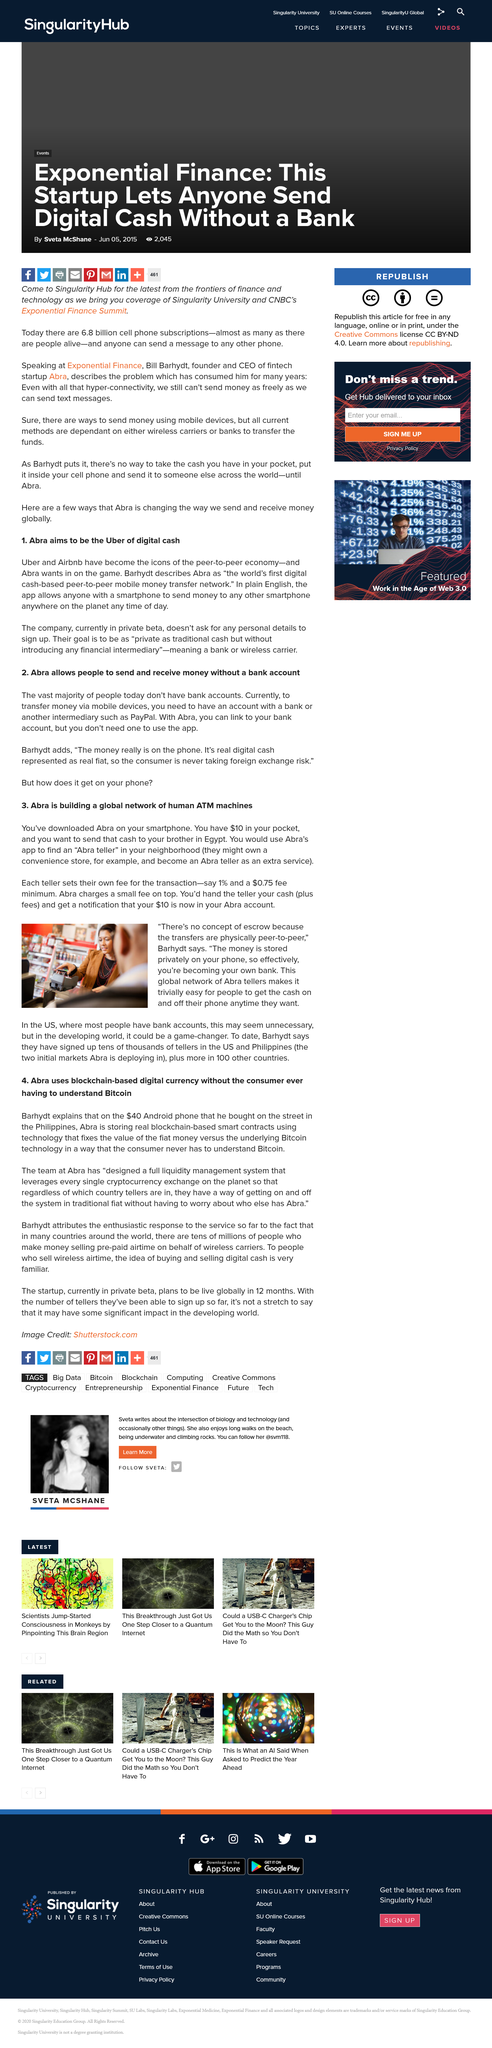Give some essential details in this illustration. Abra currently employs tens of thousands of bank tellers in the US and the Philippines, as well as in more than 100 other countries. He bought the phone on the street in the Philippines. Abra's digital currency is based on block chain technology and is designed to be used by consumers without requiring them to have knowledge of Bitcoin. Barhydt purchased an Android phone for $40. Yes, Abra charges a fee for its services. 